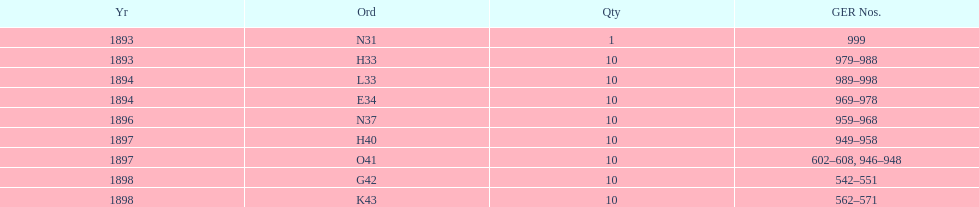Was g42 in 1898 or 1894? 1898. 